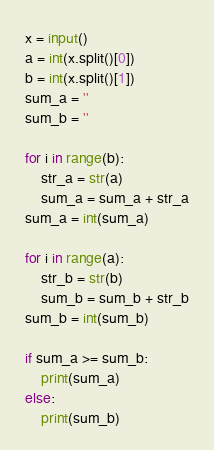Convert code to text. <code><loc_0><loc_0><loc_500><loc_500><_Python_>x = input()
a = int(x.split()[0])
b = int(x.split()[1])
sum_a = ''
sum_b = ''

for i in range(b):
    str_a = str(a)
    sum_a = sum_a + str_a
sum_a = int(sum_a)

for i in range(a):
    str_b = str(b)
    sum_b = sum_b + str_b
sum_b = int(sum_b)

if sum_a >= sum_b:
    print(sum_a)
else:
    print(sum_b)</code> 